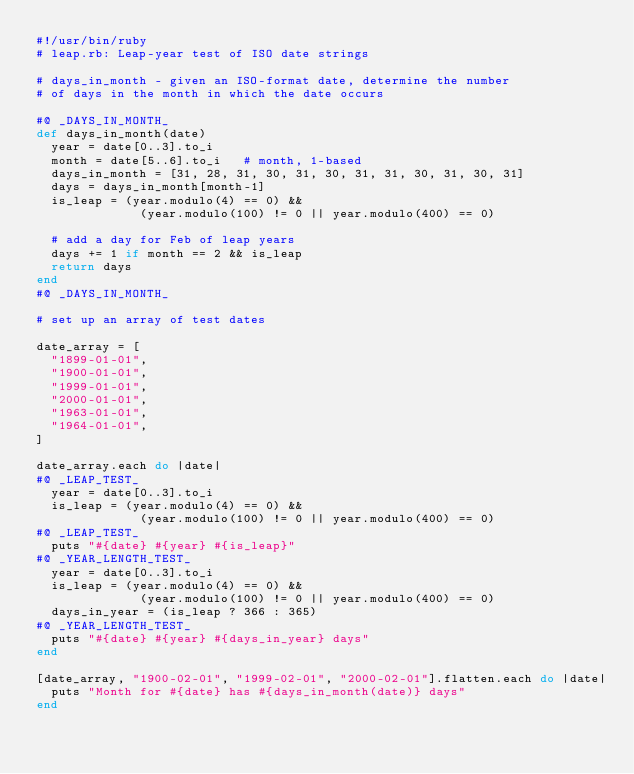Convert code to text. <code><loc_0><loc_0><loc_500><loc_500><_Ruby_>#!/usr/bin/ruby
# leap.rb: Leap-year test of ISO date strings

# days_in_month - given an ISO-format date, determine the number
# of days in the month in which the date occurs

#@ _DAYS_IN_MONTH_
def days_in_month(date)
  year = date[0..3].to_i
  month = date[5..6].to_i   # month, 1-based
  days_in_month = [31, 28, 31, 30, 31, 30, 31, 31, 30, 31, 30, 31]
  days = days_in_month[month-1]
  is_leap = (year.modulo(4) == 0) &&
              (year.modulo(100) != 0 || year.modulo(400) == 0)

  # add a day for Feb of leap years
  days += 1 if month == 2 && is_leap
  return days
end
#@ _DAYS_IN_MONTH_

# set up an array of test dates

date_array = [
  "1899-01-01",
  "1900-01-01",
  "1999-01-01",
  "2000-01-01",
  "1963-01-01",
  "1964-01-01",
]

date_array.each do |date|
#@ _LEAP_TEST_
  year = date[0..3].to_i
  is_leap = (year.modulo(4) == 0) &&
              (year.modulo(100) != 0 || year.modulo(400) == 0)
#@ _LEAP_TEST_
  puts "#{date} #{year} #{is_leap}"
#@ _YEAR_LENGTH_TEST_
  year = date[0..3].to_i
  is_leap = (year.modulo(4) == 0) &&
              (year.modulo(100) != 0 || year.modulo(400) == 0)
  days_in_year = (is_leap ? 366 : 365)
#@ _YEAR_LENGTH_TEST_
  puts "#{date} #{year} #{days_in_year} days"
end

[date_array, "1900-02-01", "1999-02-01", "2000-02-01"].flatten.each do |date|
  puts "Month for #{date} has #{days_in_month(date)} days"
end
</code> 